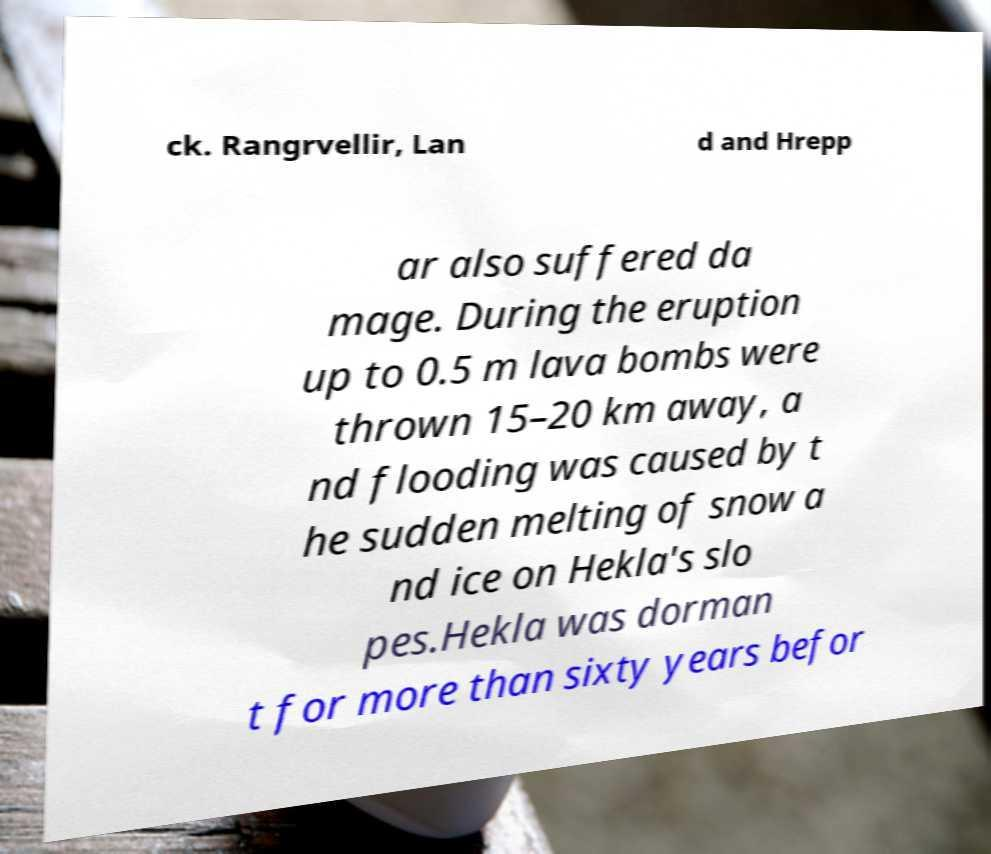There's text embedded in this image that I need extracted. Can you transcribe it verbatim? ck. Rangrvellir, Lan d and Hrepp ar also suffered da mage. During the eruption up to 0.5 m lava bombs were thrown 15–20 km away, a nd flooding was caused by t he sudden melting of snow a nd ice on Hekla's slo pes.Hekla was dorman t for more than sixty years befor 